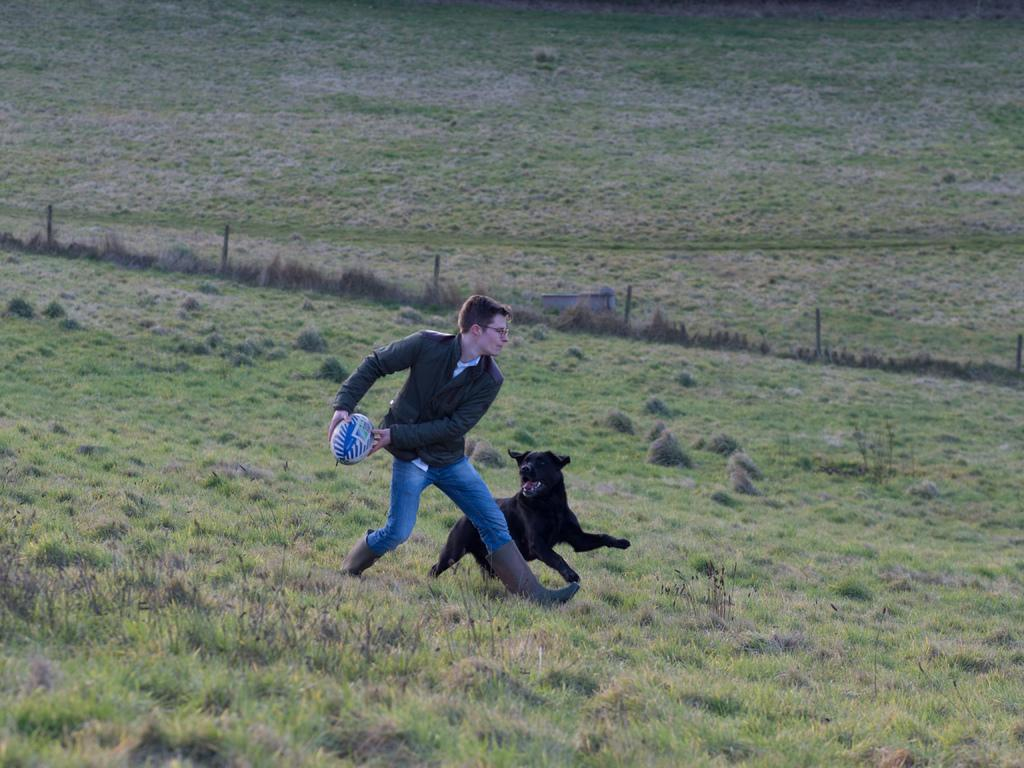What is happening in the image involving the man and the ball? The man is trying to throw a ball in the image. What is the man wearing in the image? The man is wearing a coat, trousers, and shoes in the image. What is the dog doing in the image? The dog is chasing the man in the image. What color is the dog in the image? The dog is black in color in the image. What type of surface can be seen in the image? There is grass in the image. What disease is the man suffering from in the image? There is no indication of any disease in the image; the man is simply trying to throw a ball. How many hands does the man have in the image? The image does not show the man's hands, so it is impossible to determine the number of hands he has. 